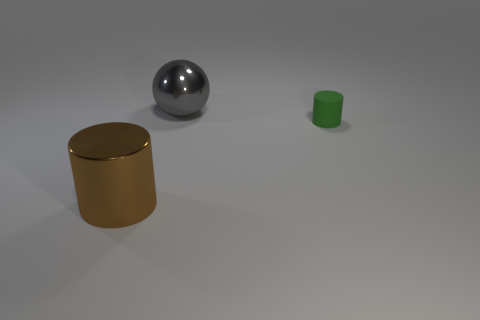Can you describe the lighting and shadows in the scene? The lighting in the scene is soft and diffuse, creating gentle shadows that extend to the right of the objects, indicating the light source is to the left. The shadows are not overly sharp, which suggests that the light source might be quite large or there may be multiple sources contributing to the overall illumination. The way the shadows are cast also adds to the sense of dimension and form of each object in the image. Does the lighting tell us anything about the environment the objects are in? The even lighting and neutral background suggest that the objects are situated in a controlled setting, such as a photography studio. The absence of additional context, like a backdrop with identifiable features, implies that the focus is on the objects themselves and their material properties rather than their environment. 